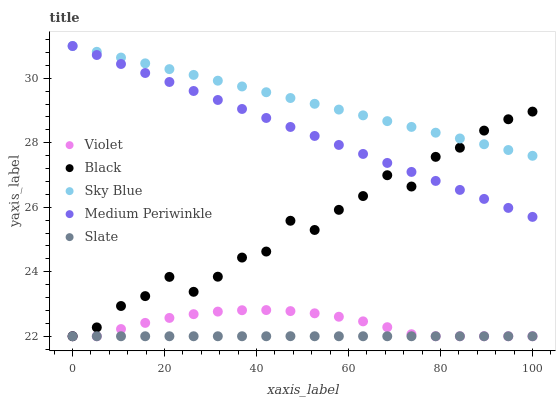Does Slate have the minimum area under the curve?
Answer yes or no. Yes. Does Sky Blue have the maximum area under the curve?
Answer yes or no. Yes. Does Black have the minimum area under the curve?
Answer yes or no. No. Does Black have the maximum area under the curve?
Answer yes or no. No. Is Medium Periwinkle the smoothest?
Answer yes or no. Yes. Is Black the roughest?
Answer yes or no. Yes. Is Slate the smoothest?
Answer yes or no. No. Is Slate the roughest?
Answer yes or no. No. Does Slate have the lowest value?
Answer yes or no. Yes. Does Medium Periwinkle have the lowest value?
Answer yes or no. No. Does Medium Periwinkle have the highest value?
Answer yes or no. Yes. Does Black have the highest value?
Answer yes or no. No. Is Violet less than Sky Blue?
Answer yes or no. Yes. Is Medium Periwinkle greater than Slate?
Answer yes or no. Yes. Does Violet intersect Black?
Answer yes or no. Yes. Is Violet less than Black?
Answer yes or no. No. Is Violet greater than Black?
Answer yes or no. No. Does Violet intersect Sky Blue?
Answer yes or no. No. 